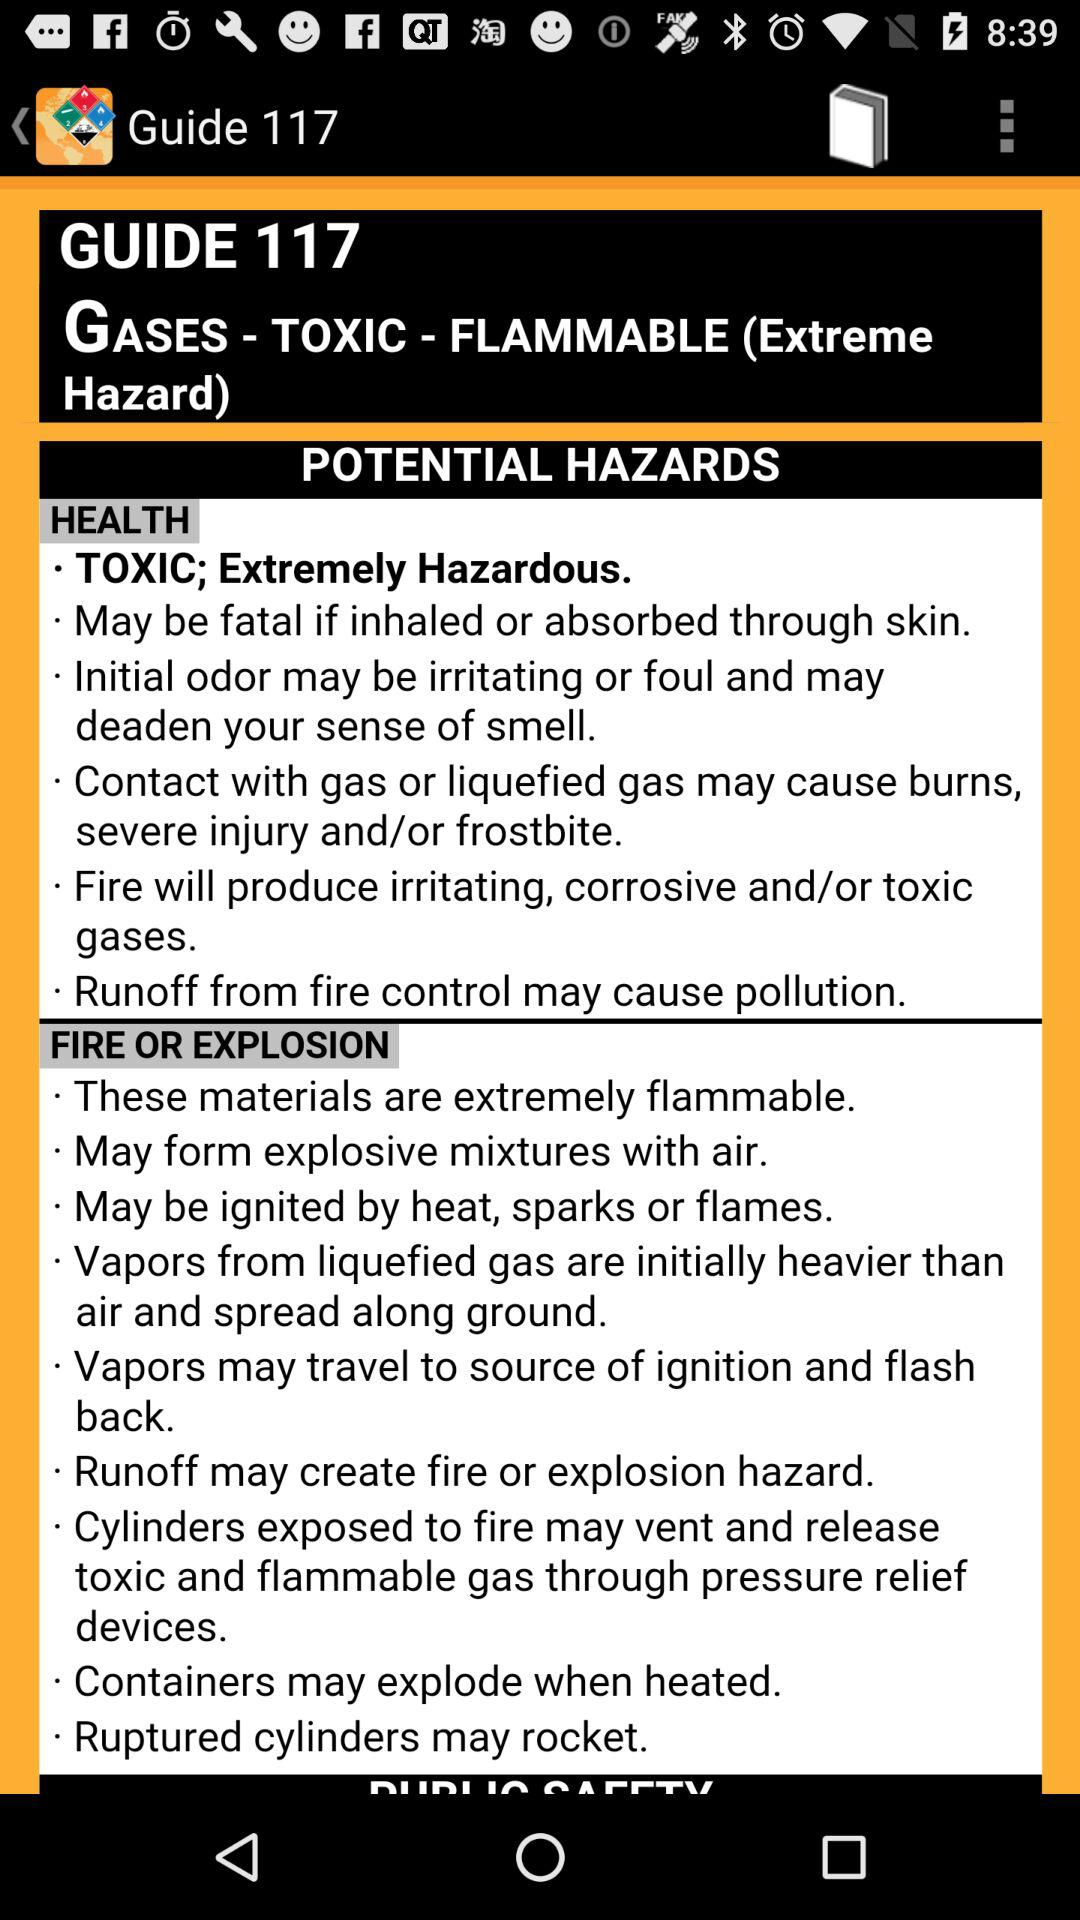What is the guide number? The guide number is 117. 